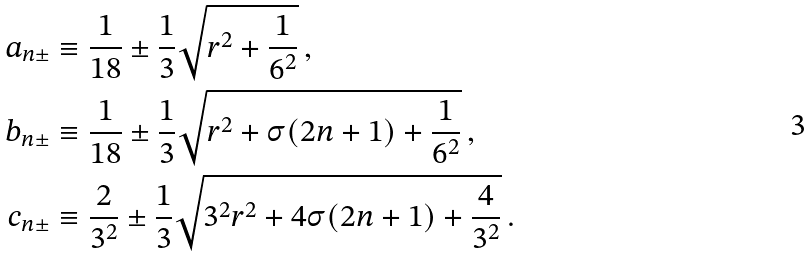<formula> <loc_0><loc_0><loc_500><loc_500>a _ { n \pm } & \equiv \frac { 1 } { 1 8 } \pm \frac { 1 } { 3 } \sqrt { r ^ { 2 } + \frac { 1 } { 6 ^ { 2 } } } \, , \\ b _ { n \pm } & \equiv \frac { 1 } { 1 8 } \pm \frac { 1 } { 3 } \sqrt { r ^ { 2 } + \sigma ( 2 n + 1 ) + \frac { 1 } { 6 ^ { 2 } } } \, , \\ c _ { n \pm } & \equiv \frac { 2 } { 3 ^ { 2 } } \pm \frac { 1 } { 3 } \sqrt { 3 ^ { 2 } r ^ { 2 } + 4 \sigma ( 2 n + 1 ) + \frac { 4 } { 3 ^ { 2 } } } \, .</formula> 